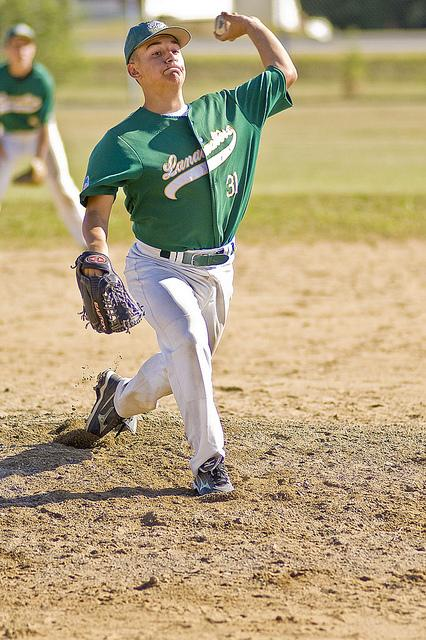Where does this man?

Choices:
A) dugout
B) home plate
C) outfield
D) pitchers mound pitchers mound 